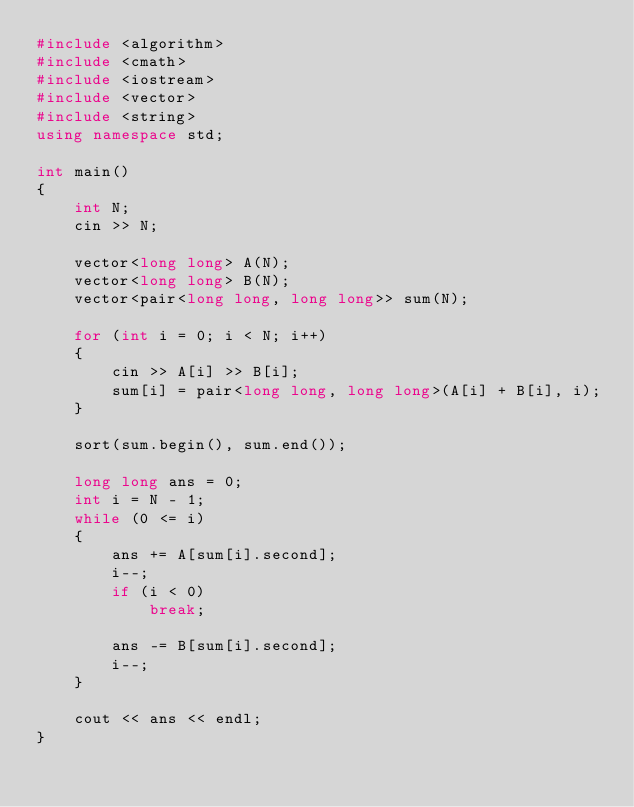<code> <loc_0><loc_0><loc_500><loc_500><_C++_>#include <algorithm>
#include <cmath>
#include <iostream>
#include <vector>
#include <string>
using namespace std;

int main()
{
    int N;
    cin >> N;

    vector<long long> A(N);
    vector<long long> B(N);
    vector<pair<long long, long long>> sum(N);

    for (int i = 0; i < N; i++)
    {
        cin >> A[i] >> B[i];
        sum[i] = pair<long long, long long>(A[i] + B[i], i);
    }

    sort(sum.begin(), sum.end());

    long long ans = 0;
    int i = N - 1;
    while (0 <= i)
    {
        ans += A[sum[i].second];
        i--;
        if (i < 0)
            break;

        ans -= B[sum[i].second];
        i--;
    }

    cout << ans << endl;
}</code> 